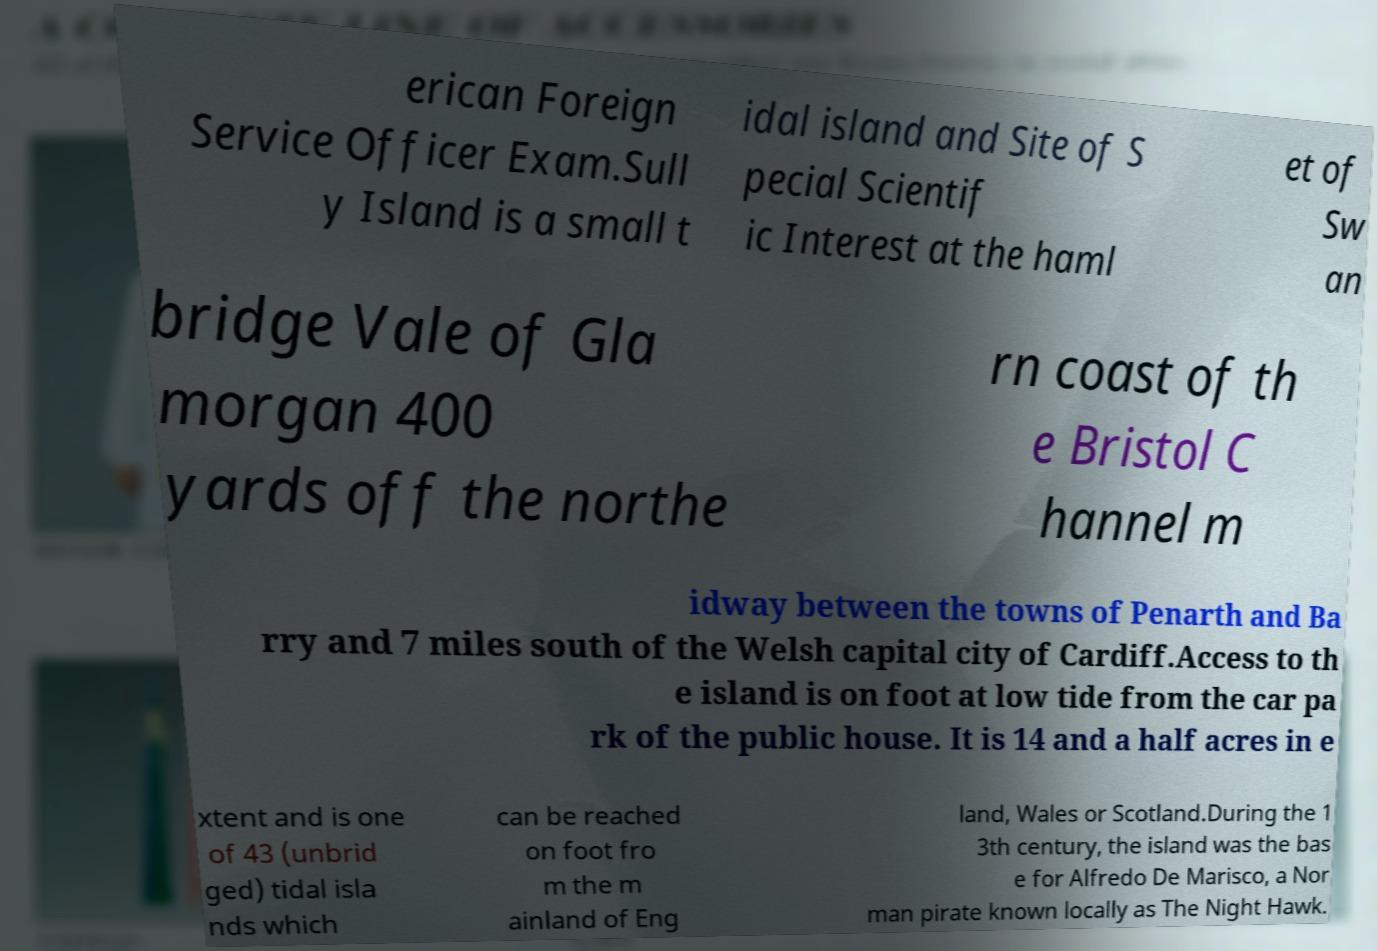Can you read and provide the text displayed in the image?This photo seems to have some interesting text. Can you extract and type it out for me? erican Foreign Service Officer Exam.Sull y Island is a small t idal island and Site of S pecial Scientif ic Interest at the haml et of Sw an bridge Vale of Gla morgan 400 yards off the northe rn coast of th e Bristol C hannel m idway between the towns of Penarth and Ba rry and 7 miles south of the Welsh capital city of Cardiff.Access to th e island is on foot at low tide from the car pa rk of the public house. It is 14 and a half acres in e xtent and is one of 43 (unbrid ged) tidal isla nds which can be reached on foot fro m the m ainland of Eng land, Wales or Scotland.During the 1 3th century, the island was the bas e for Alfredo De Marisco, a Nor man pirate known locally as The Night Hawk. 